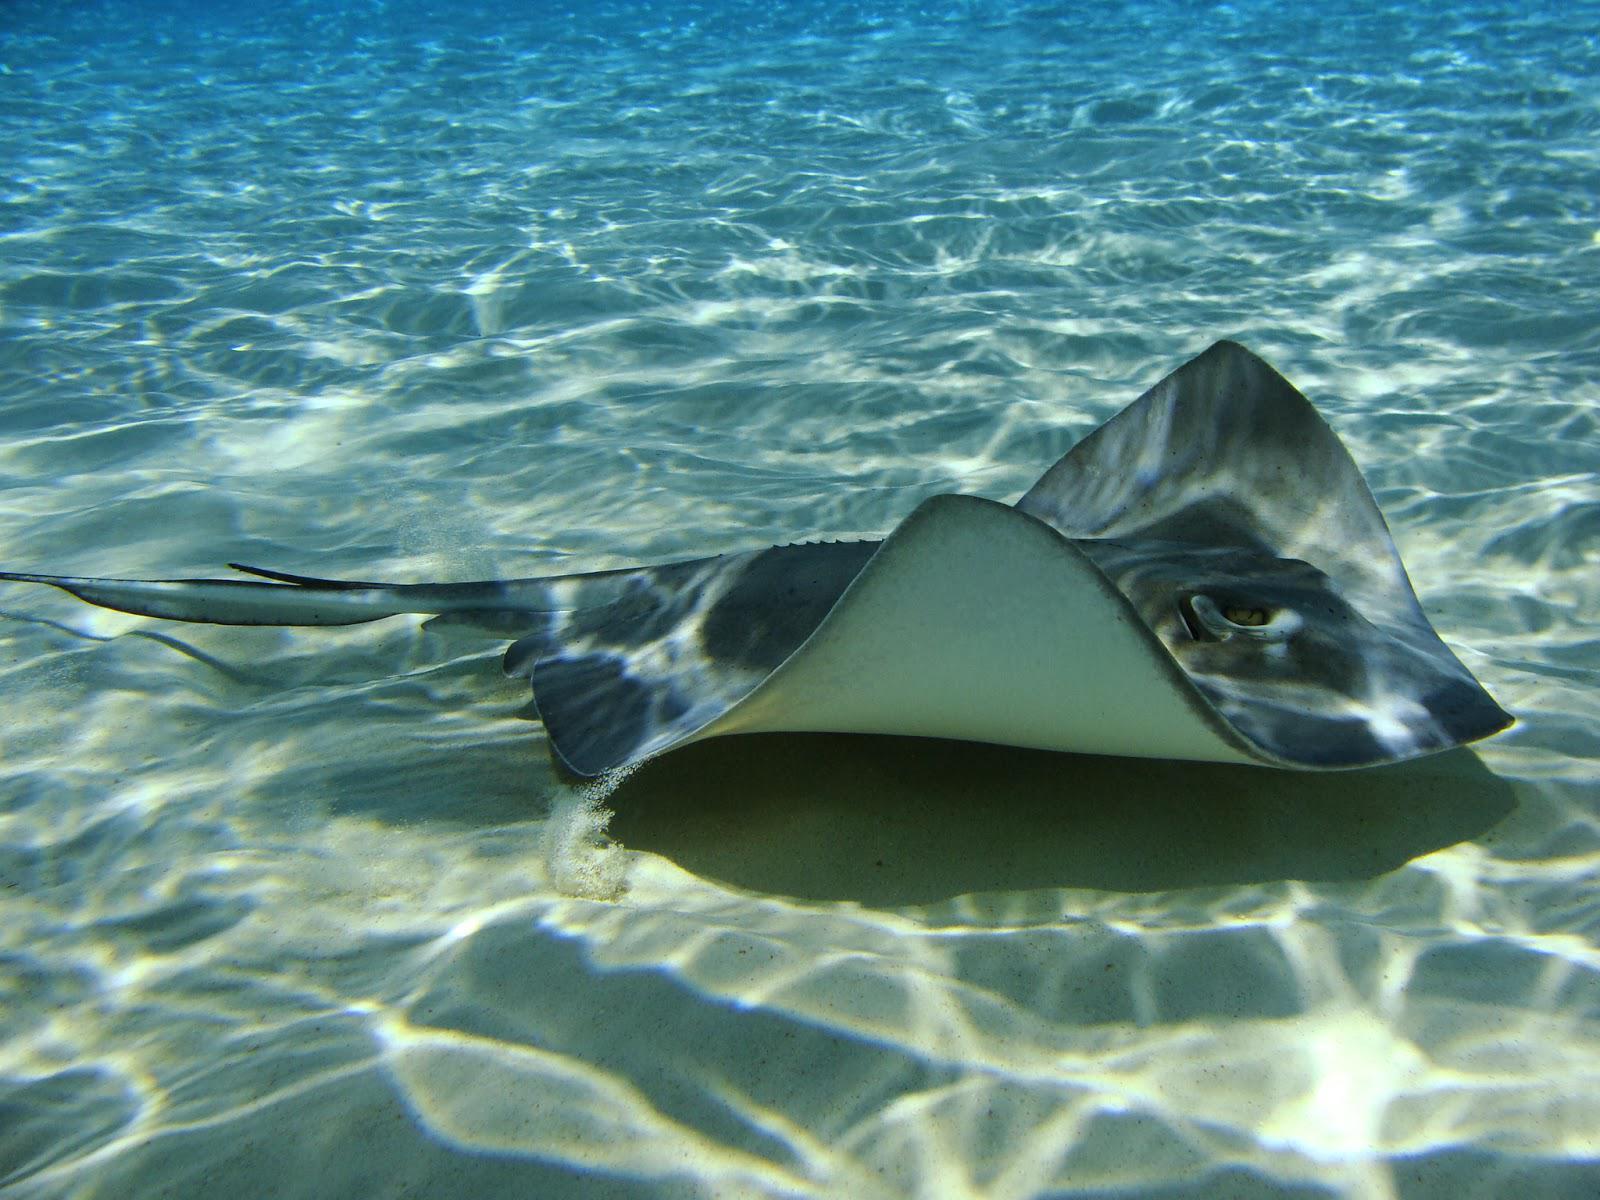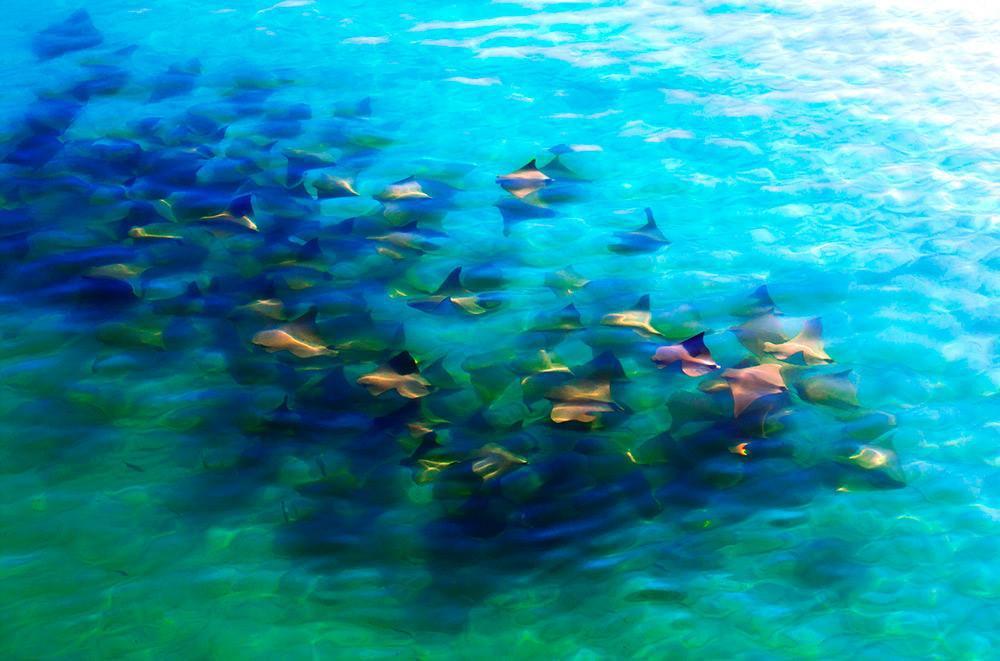The first image is the image on the left, the second image is the image on the right. Analyze the images presented: Is the assertion "In the left image the stingray is near the seabed." valid? Answer yes or no. Yes. The first image is the image on the left, the second image is the image on the right. Examine the images to the left and right. Is the description "The left image contains no more than five sting rays." accurate? Answer yes or no. Yes. 